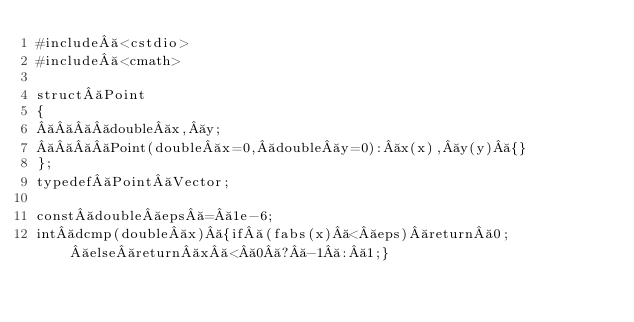<code> <loc_0><loc_0><loc_500><loc_500><_C++_>#include <cstdio>
#include <cmath>

struct Point
{
    double x, y;
    Point(double x=0, double y=0): x(x), y(y) {}
};
typedef Point Vector;

const double eps = 1e-6;
int dcmp(double x) {if (fabs(x) < eps) return 0; else return x < 0 ? -1 : 1;}</code> 